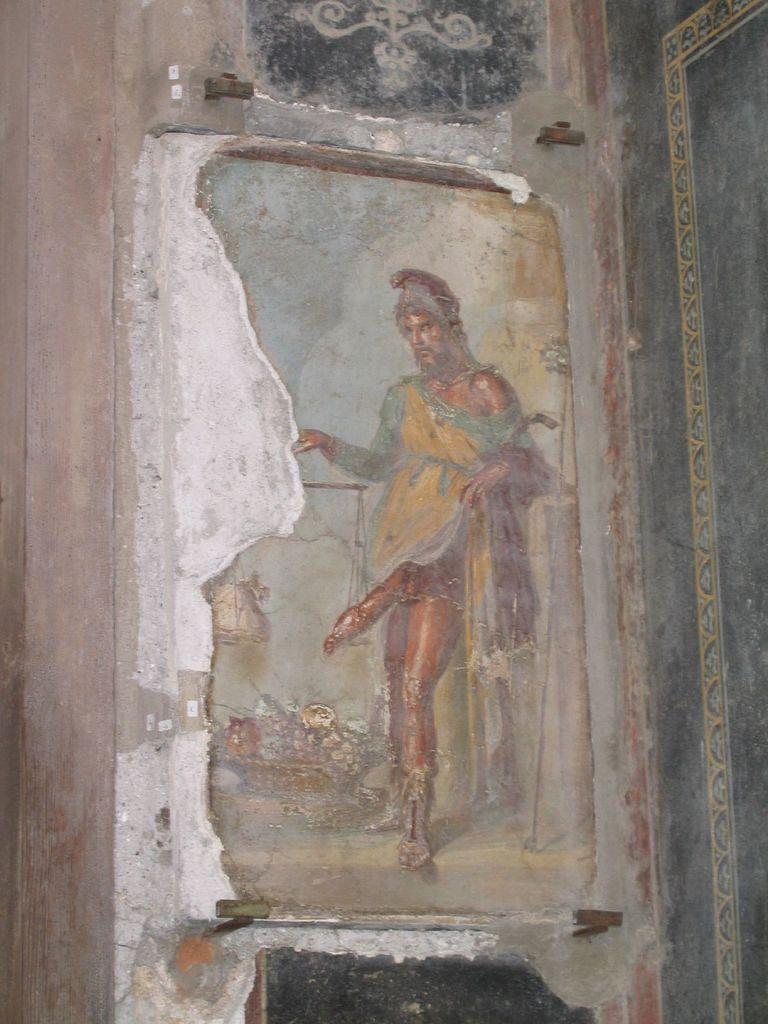Please provide a concise description of this image. In this image, we can see the poster of a person on the wall. 